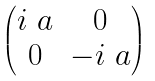Convert formula to latex. <formula><loc_0><loc_0><loc_500><loc_500>\begin{pmatrix} i \ a & 0 \\ 0 & - i \ a \end{pmatrix}</formula> 